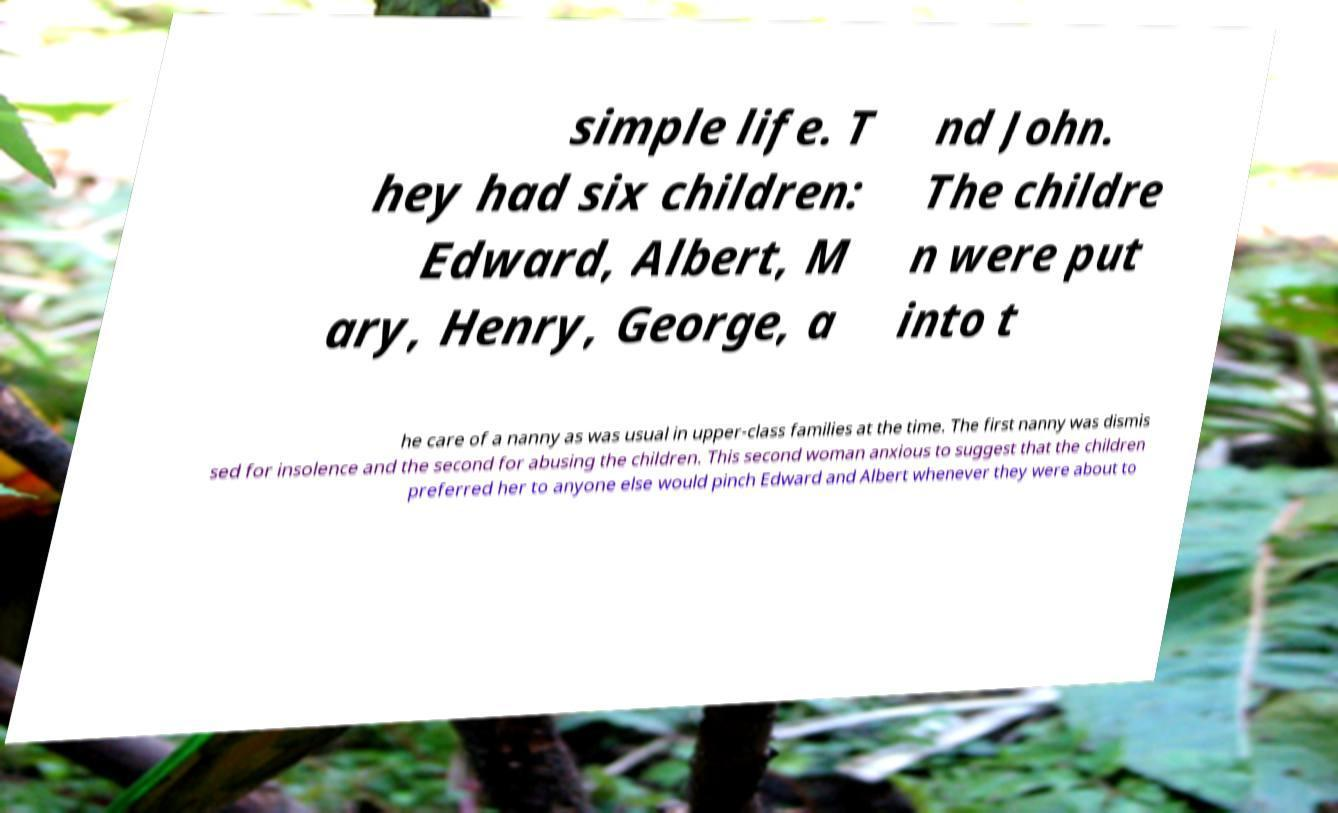What messages or text are displayed in this image? I need them in a readable, typed format. simple life. T hey had six children: Edward, Albert, M ary, Henry, George, a nd John. The childre n were put into t he care of a nanny as was usual in upper-class families at the time. The first nanny was dismis sed for insolence and the second for abusing the children. This second woman anxious to suggest that the children preferred her to anyone else would pinch Edward and Albert whenever they were about to 